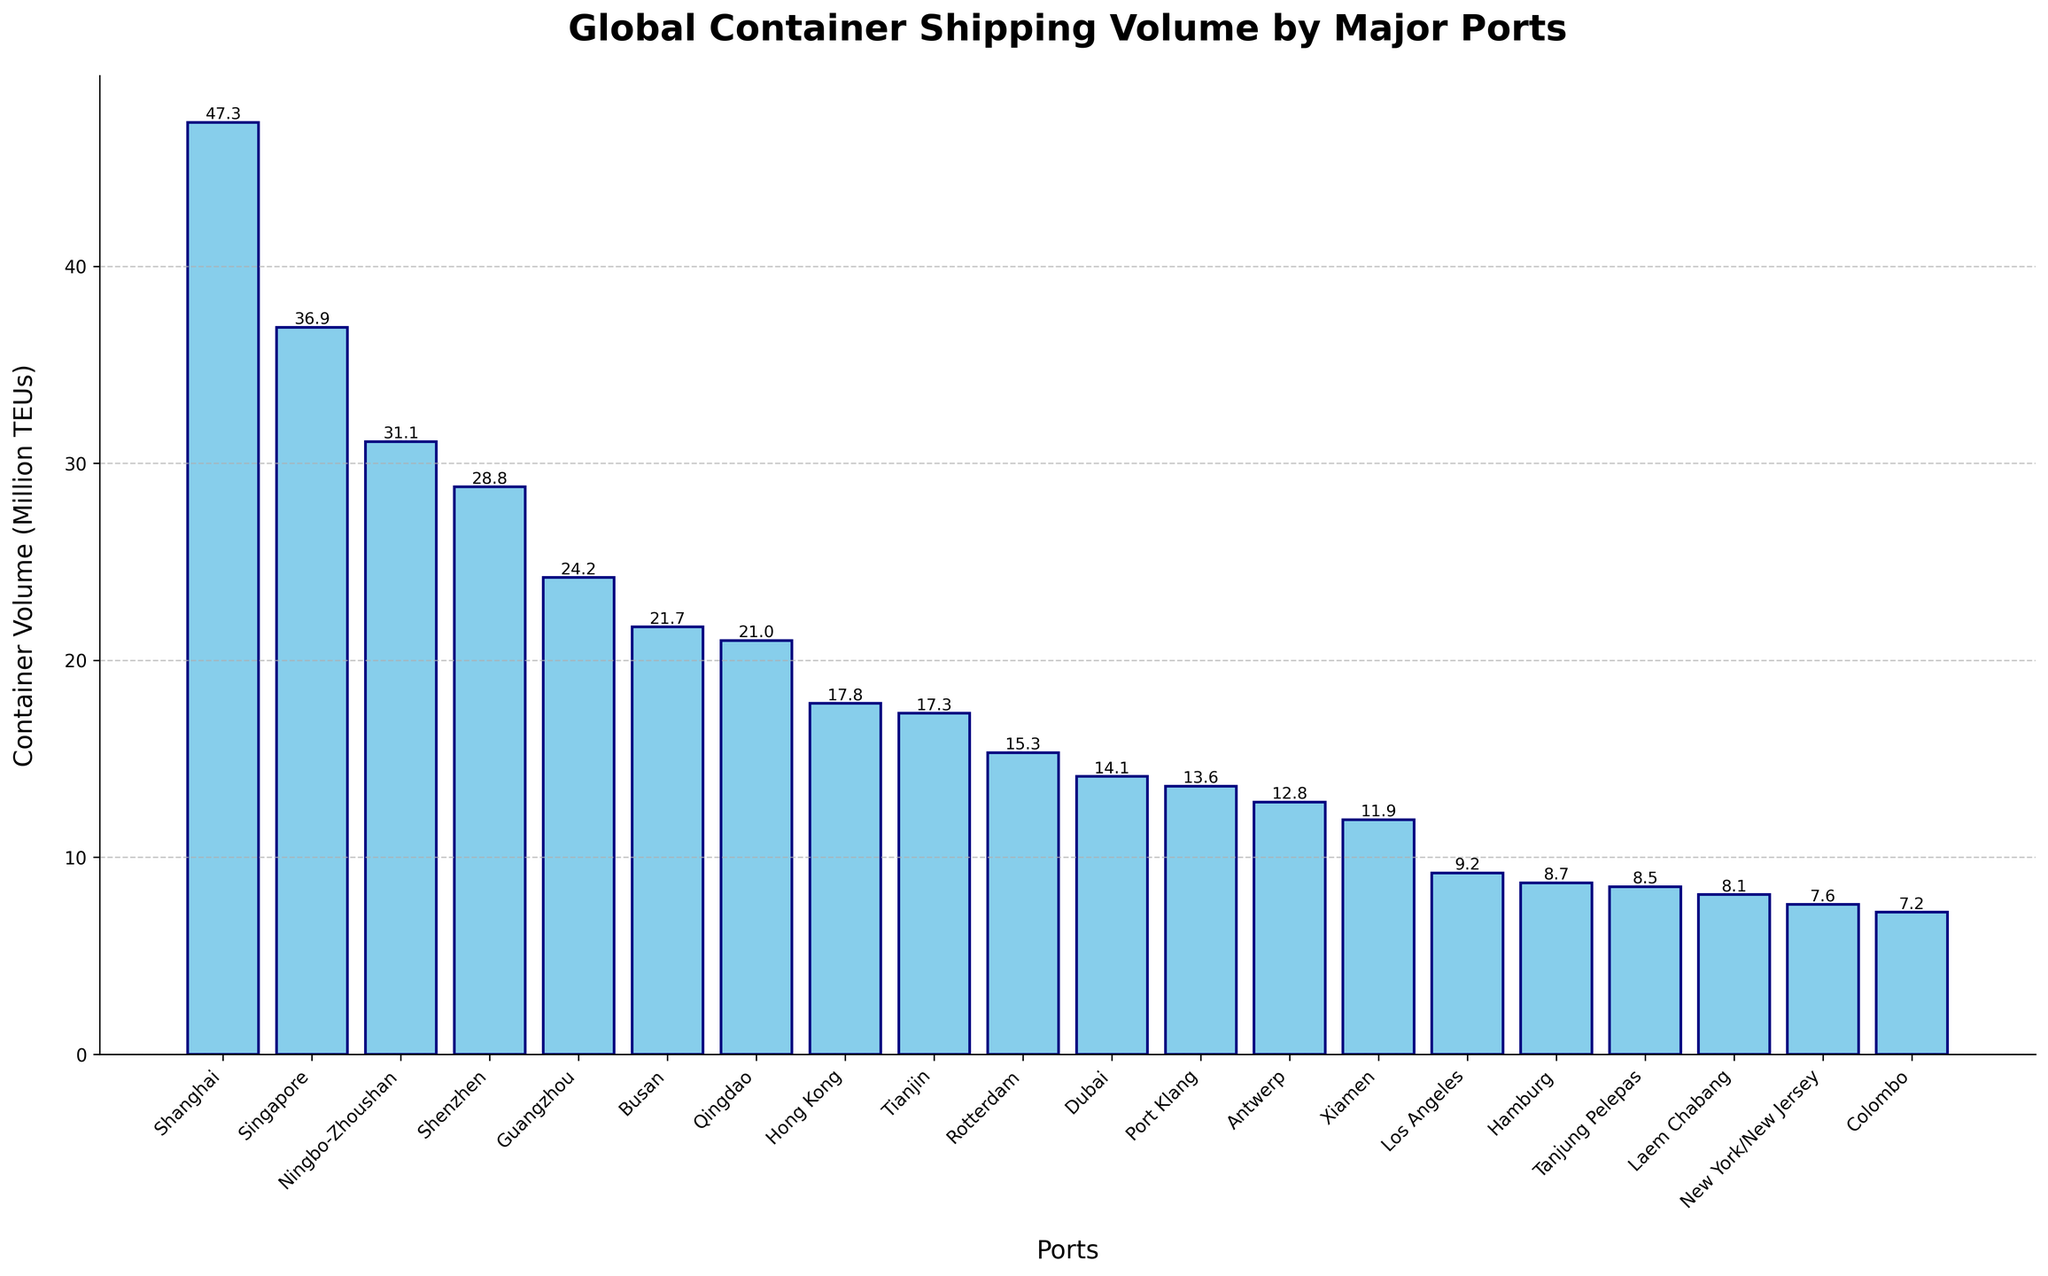Which port has the highest container shipping volume? By looking at the heights of the bars, we can see that the bar representing Shanghai is the tallest. This indicates that Shanghai has the highest container shipping volume.
Answer: Shanghai Which port has the lowest container shipping volume? Observing the heights of the bars, we can see that the bar representing New York/New Jersey is the shortest. This indicates that New York/New Jersey has the lowest container shipping volume.
Answer: New York/New Jersey What is the combined container volume of the top three ports? The top three ports are Shanghai, Singapore, and Ningbo-Zhoushan. Summing their volumes: 47.3 + 36.9 + 31.1 = 115.3 million TEUs.
Answer: 115.3 million TEUs How much more container volume does Shanghai have compared to Los Angeles? The container volume for Shanghai is 47.3 million TEUs, and for Los Angeles, it is 9.2 million TEUs. The difference is 47.3 - 9.2 = 38.1 million TEUs.
Answer: 38.1 million TEUs What is the average container volume of all the ports listed? Summing up the container volumes for all ports: 47.3 + 36.9 + 31.1 + 28.8 + 24.2 + 21.7 + 21.0 + 17.8 + 17.3 + 15.3 + 13.6 + 12.8 + 11.9 + 9.2 + 8.7 + 8.5 + 8.1 + 7.6 + 7.2 + 14.1 = 363.1 million TEUs. There are 20 ports, so the average is 363.1 / 20 = 18.155 million TEUs.
Answer: 18.155 million TEUs Which port handles more container volume, Rotterdam or Dubai? Comparing the heights of the bars for Rotterdam and Dubai, the bar for Dubai is higher. This indicates that Dubai handles more container volume than Rotterdam.
Answer: Dubai How many ports handle 20 million TEUs or more? By counting the bars that reach or exceed the 20 million TEUs mark, there are 6 ports: Shanghai, Singapore, Ningbo-Zhoushan, Shenzhen, Guangzhou, and Busan.
Answer: 6 What is the total container volume handled by the ports in China? Considering the ports: Shanghai, Ningbo-Zhoushan, Shenzhen, Guangzhou, Qingdao, Hong Kong, Tianjin, and Xiamen, their volumes are: 47.3 + 31.1 + 28.8 + 24.2 + 21.0 + 17.8 + 17.3 + 11.9 = 199.4 million TEUs.
Answer: 199.4 million TEUs How does the container volume of Rotterdam compare to that of Antwerp and Tanjung Pelepas combined? The container volume for Rotterdam is 15.3 million TEUs. The combined volume for Antwerp (12.8 million TEUs) and Tanjung Pelepas (8.5 million TEUs) is 12.8 + 8.5 = 21.3 million TEUs. Rotterdam's volume is less than the combined volume of Antwerp and Tanjung Pelepas.
Answer: Less What is the range of container volumes among the listed ports? The range is the difference between the highest volume and the lowest volume. Shanghai has the highest volume at 47.3 million TEUs, and New York/New Jersey has the lowest at 7.6 million TEUs. The range is 47.3 - 7.6 = 39.7 million TEUs.
Answer: 39.7 million TEUs 